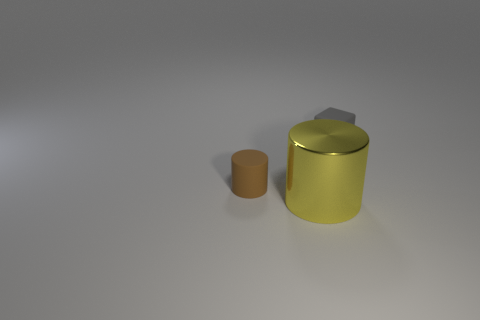How many other things are there of the same size as the block?
Ensure brevity in your answer.  1. What size is the cylinder that is in front of the matte object that is left of the small gray rubber thing?
Your answer should be very brief. Large. There is a thing that is made of the same material as the small cube; what color is it?
Provide a succinct answer. Brown. What number of things are the same size as the metallic cylinder?
Offer a very short reply. 0. How many brown objects are either large shiny objects or tiny objects?
Make the answer very short. 1. How many objects are either large green metal spheres or objects that are to the left of the big thing?
Make the answer very short. 1. There is a small thing that is on the left side of the tiny matte cube; what material is it?
Give a very brief answer. Rubber. What shape is the matte thing that is the same size as the matte cylinder?
Your answer should be very brief. Cube. Is there another small thing of the same shape as the small gray rubber object?
Your response must be concise. No. Are the brown cylinder and the cylinder to the right of the tiny brown matte cylinder made of the same material?
Make the answer very short. No. 